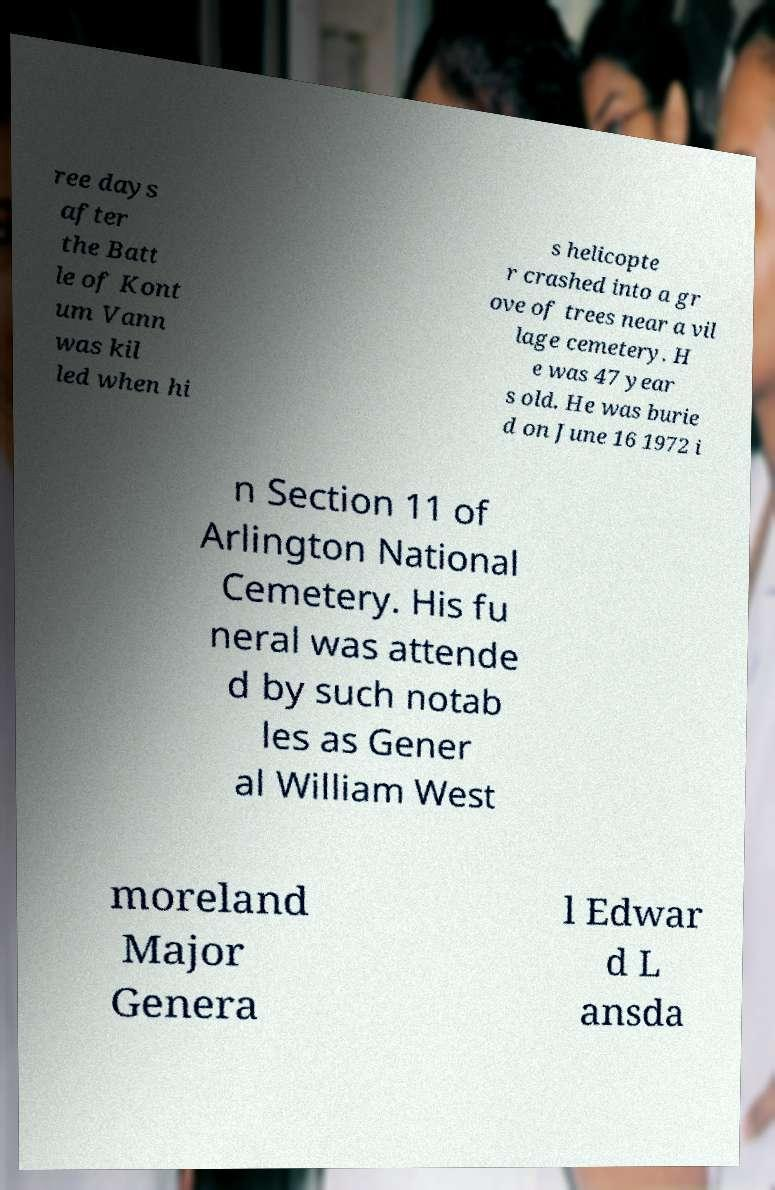Could you extract and type out the text from this image? ree days after the Batt le of Kont um Vann was kil led when hi s helicopte r crashed into a gr ove of trees near a vil lage cemetery. H e was 47 year s old. He was burie d on June 16 1972 i n Section 11 of Arlington National Cemetery. His fu neral was attende d by such notab les as Gener al William West moreland Major Genera l Edwar d L ansda 